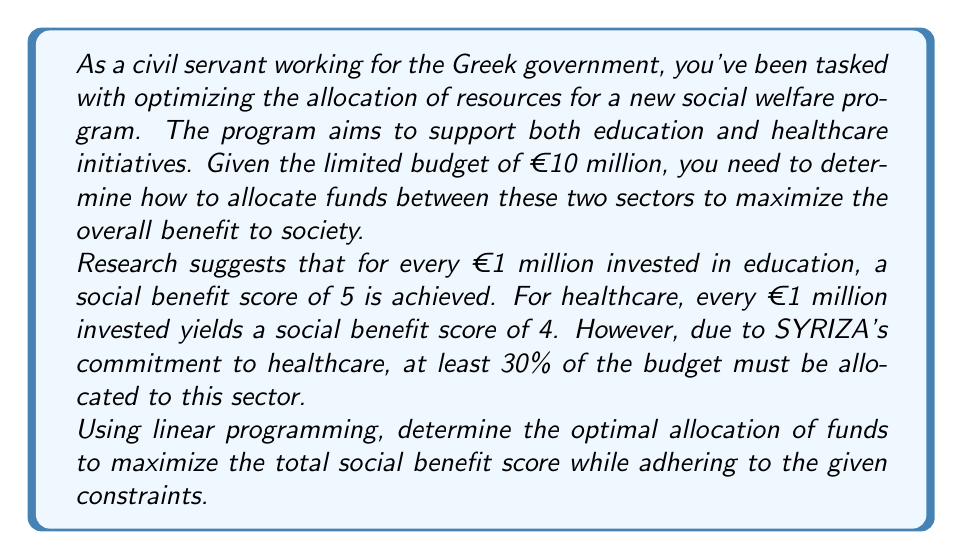Can you answer this question? Let's approach this problem using linear programming:

1) Define variables:
   Let $x$ = amount invested in education (in millions of €)
   Let $y$ = amount invested in healthcare (in millions of €)

2) Objective function:
   We want to maximize the total social benefit score
   Maximize: $Z = 5x + 4y$

3) Constraints:
   a) Total budget constraint: $x + y \leq 10$
   b) Healthcare must receive at least 30% of budget: $y \geq 0.3(x + y)$
   c) Non-negativity constraints: $x \geq 0, y \geq 0$

4) Solve using the graphical method:

   From constraint (b): $y \geq 0.3(x + y)$
                        $0.7y \geq 0.3x$
                        $y \geq \frac{3}{7}x$

   Plot the constraints:
   $$
   \begin{aligned}
   x + y &= 10 \\
   y &= \frac{3}{7}x \\
   x &= 0 \\
   y &= 0
   \end{aligned}
   $$

5) Find the vertices of the feasible region:
   - (0, 10)
   - (7, 3)
   - (0, 0)

6) Evaluate the objective function at these points:
   - At (0, 10): $Z = 5(0) + 4(10) = 40$
   - At (7, 3): $Z = 5(7) + 4(3) = 47$
   - At (0, 0): $Z = 5(0) + 4(0) = 0$

7) The maximum value occurs at (7, 3), so this is our optimal solution.

Therefore, the optimal allocation is €7 million to education and €3 million to healthcare, resulting in a maximum social benefit score of 47.
Answer: The optimal allocation is €7 million to education and €3 million to healthcare, yielding a maximum social benefit score of 47. 